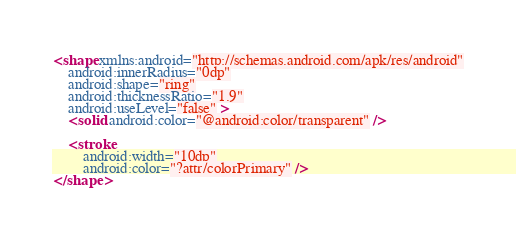<code> <loc_0><loc_0><loc_500><loc_500><_XML_><shape xmlns:android="http://schemas.android.com/apk/res/android"
    android:innerRadius="0dp"
    android:shape="ring"
    android:thicknessRatio="1.9"
    android:useLevel="false" >
    <solid android:color="@android:color/transparent" />

    <stroke
        android:width="10dp"
        android:color="?attr/colorPrimary" />
</shape></code> 